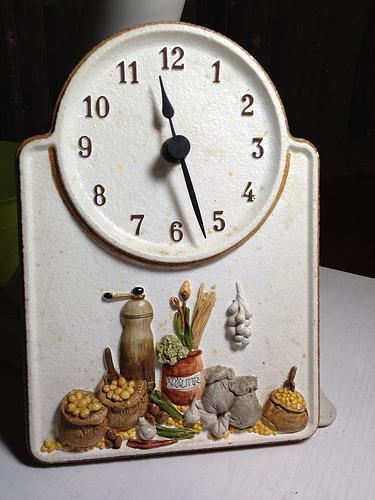How many clocks can we see?
Give a very brief answer. 1. 